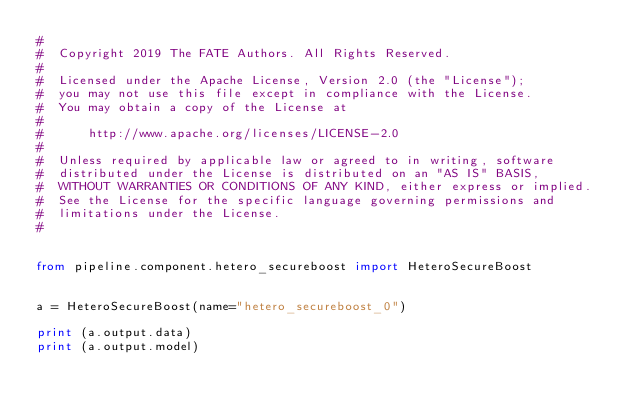<code> <loc_0><loc_0><loc_500><loc_500><_Python_>#
#  Copyright 2019 The FATE Authors. All Rights Reserved.
#
#  Licensed under the Apache License, Version 2.0 (the "License");
#  you may not use this file except in compliance with the License.
#  You may obtain a copy of the License at
#
#      http://www.apache.org/licenses/LICENSE-2.0
#
#  Unless required by applicable law or agreed to in writing, software
#  distributed under the License is distributed on an "AS IS" BASIS,
#  WITHOUT WARRANTIES OR CONDITIONS OF ANY KIND, either express or implied.
#  See the License for the specific language governing permissions and
#  limitations under the License.
#


from pipeline.component.hetero_secureboost import HeteroSecureBoost


a = HeteroSecureBoost(name="hetero_secureboost_0")

print (a.output.data)
print (a.output.model)
</code> 